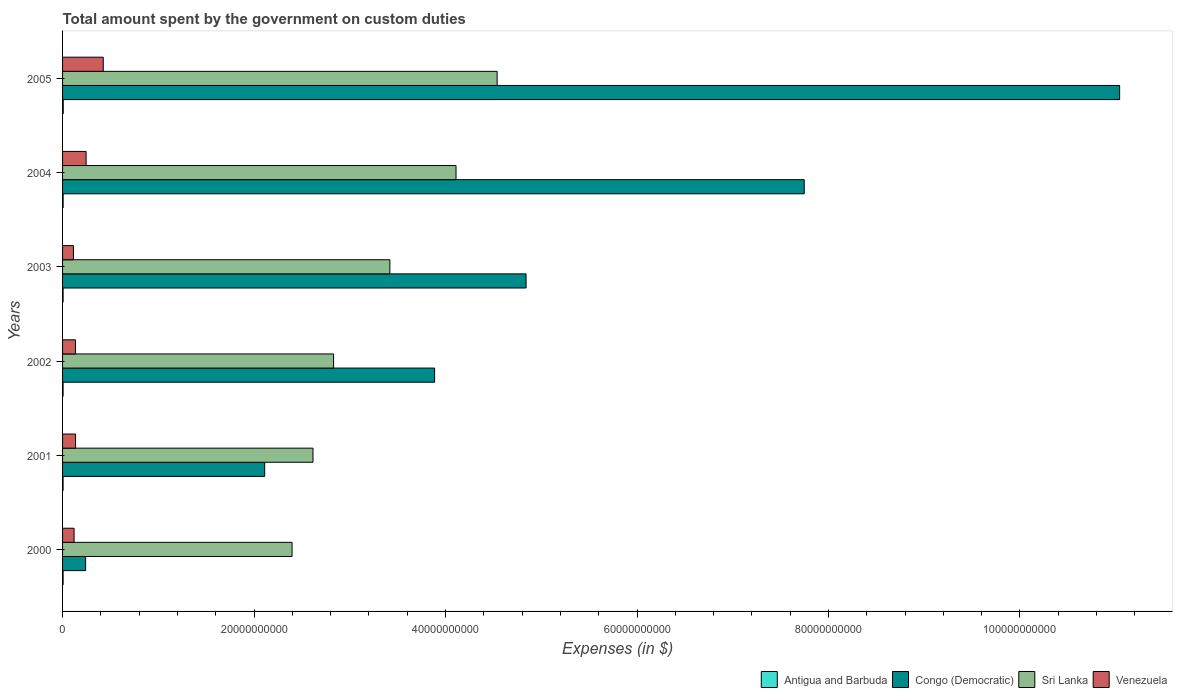How many groups of bars are there?
Provide a short and direct response. 6. How many bars are there on the 5th tick from the bottom?
Provide a short and direct response. 4. What is the amount spent on custom duties by the government in Venezuela in 2005?
Provide a short and direct response. 4.25e+09. Across all years, what is the maximum amount spent on custom duties by the government in Sri Lanka?
Provide a short and direct response. 4.54e+1. Across all years, what is the minimum amount spent on custom duties by the government in Sri Lanka?
Ensure brevity in your answer.  2.40e+1. In which year was the amount spent on custom duties by the government in Antigua and Barbuda maximum?
Make the answer very short. 2005. In which year was the amount spent on custom duties by the government in Congo (Democratic) minimum?
Your answer should be compact. 2000. What is the total amount spent on custom duties by the government in Sri Lanka in the graph?
Provide a short and direct response. 1.99e+11. What is the difference between the amount spent on custom duties by the government in Venezuela in 2000 and that in 2002?
Offer a very short reply. -1.48e+08. What is the difference between the amount spent on custom duties by the government in Congo (Democratic) in 2005 and the amount spent on custom duties by the government in Antigua and Barbuda in 2001?
Keep it short and to the point. 1.10e+11. What is the average amount spent on custom duties by the government in Congo (Democratic) per year?
Make the answer very short. 4.98e+1. In the year 2002, what is the difference between the amount spent on custom duties by the government in Sri Lanka and amount spent on custom duties by the government in Antigua and Barbuda?
Give a very brief answer. 2.83e+1. In how many years, is the amount spent on custom duties by the government in Sri Lanka greater than 32000000000 $?
Your answer should be compact. 3. What is the ratio of the amount spent on custom duties by the government in Congo (Democratic) in 2002 to that in 2004?
Offer a terse response. 0.5. What is the difference between the highest and the second highest amount spent on custom duties by the government in Antigua and Barbuda?
Your response must be concise. 1.07e+07. What is the difference between the highest and the lowest amount spent on custom duties by the government in Antigua and Barbuda?
Offer a terse response. 1.66e+07. Is it the case that in every year, the sum of the amount spent on custom duties by the government in Sri Lanka and amount spent on custom duties by the government in Venezuela is greater than the sum of amount spent on custom duties by the government in Congo (Democratic) and amount spent on custom duties by the government in Antigua and Barbuda?
Your answer should be compact. Yes. What does the 1st bar from the top in 2002 represents?
Your answer should be compact. Venezuela. What does the 2nd bar from the bottom in 2003 represents?
Give a very brief answer. Congo (Democratic). Does the graph contain any zero values?
Your answer should be compact. No. What is the title of the graph?
Provide a short and direct response. Total amount spent by the government on custom duties. Does "Latin America(all income levels)" appear as one of the legend labels in the graph?
Provide a short and direct response. No. What is the label or title of the X-axis?
Your response must be concise. Expenses (in $). What is the label or title of the Y-axis?
Your response must be concise. Years. What is the Expenses (in $) in Antigua and Barbuda in 2000?
Ensure brevity in your answer.  5.67e+07. What is the Expenses (in $) in Congo (Democratic) in 2000?
Provide a short and direct response. 2.41e+09. What is the Expenses (in $) in Sri Lanka in 2000?
Give a very brief answer. 2.40e+1. What is the Expenses (in $) in Venezuela in 2000?
Keep it short and to the point. 1.20e+09. What is the Expenses (in $) of Antigua and Barbuda in 2001?
Keep it short and to the point. 5.59e+07. What is the Expenses (in $) of Congo (Democratic) in 2001?
Make the answer very short. 2.11e+1. What is the Expenses (in $) in Sri Lanka in 2001?
Provide a succinct answer. 2.62e+1. What is the Expenses (in $) of Venezuela in 2001?
Give a very brief answer. 1.36e+09. What is the Expenses (in $) of Antigua and Barbuda in 2002?
Your response must be concise. 5.46e+07. What is the Expenses (in $) in Congo (Democratic) in 2002?
Your answer should be very brief. 3.89e+1. What is the Expenses (in $) of Sri Lanka in 2002?
Your answer should be compact. 2.83e+1. What is the Expenses (in $) in Venezuela in 2002?
Provide a succinct answer. 1.35e+09. What is the Expenses (in $) in Antigua and Barbuda in 2003?
Make the answer very short. 5.70e+07. What is the Expenses (in $) of Congo (Democratic) in 2003?
Make the answer very short. 4.84e+1. What is the Expenses (in $) of Sri Lanka in 2003?
Your answer should be very brief. 3.42e+1. What is the Expenses (in $) of Venezuela in 2003?
Keep it short and to the point. 1.14e+09. What is the Expenses (in $) of Antigua and Barbuda in 2004?
Make the answer very short. 6.05e+07. What is the Expenses (in $) in Congo (Democratic) in 2004?
Ensure brevity in your answer.  7.75e+1. What is the Expenses (in $) of Sri Lanka in 2004?
Your response must be concise. 4.11e+1. What is the Expenses (in $) of Venezuela in 2004?
Provide a succinct answer. 2.46e+09. What is the Expenses (in $) in Antigua and Barbuda in 2005?
Offer a terse response. 7.12e+07. What is the Expenses (in $) of Congo (Democratic) in 2005?
Give a very brief answer. 1.10e+11. What is the Expenses (in $) in Sri Lanka in 2005?
Ensure brevity in your answer.  4.54e+1. What is the Expenses (in $) in Venezuela in 2005?
Make the answer very short. 4.25e+09. Across all years, what is the maximum Expenses (in $) in Antigua and Barbuda?
Provide a short and direct response. 7.12e+07. Across all years, what is the maximum Expenses (in $) in Congo (Democratic)?
Ensure brevity in your answer.  1.10e+11. Across all years, what is the maximum Expenses (in $) in Sri Lanka?
Offer a very short reply. 4.54e+1. Across all years, what is the maximum Expenses (in $) in Venezuela?
Offer a terse response. 4.25e+09. Across all years, what is the minimum Expenses (in $) of Antigua and Barbuda?
Offer a very short reply. 5.46e+07. Across all years, what is the minimum Expenses (in $) in Congo (Democratic)?
Your answer should be very brief. 2.41e+09. Across all years, what is the minimum Expenses (in $) of Sri Lanka?
Offer a terse response. 2.40e+1. Across all years, what is the minimum Expenses (in $) in Venezuela?
Offer a very short reply. 1.14e+09. What is the total Expenses (in $) of Antigua and Barbuda in the graph?
Give a very brief answer. 3.56e+08. What is the total Expenses (in $) of Congo (Democratic) in the graph?
Offer a very short reply. 2.99e+11. What is the total Expenses (in $) of Sri Lanka in the graph?
Give a very brief answer. 1.99e+11. What is the total Expenses (in $) in Venezuela in the graph?
Ensure brevity in your answer.  1.18e+1. What is the difference between the Expenses (in $) of Congo (Democratic) in 2000 and that in 2001?
Offer a terse response. -1.87e+1. What is the difference between the Expenses (in $) in Sri Lanka in 2000 and that in 2001?
Make the answer very short. -2.19e+09. What is the difference between the Expenses (in $) in Venezuela in 2000 and that in 2001?
Your answer should be very brief. -1.52e+08. What is the difference between the Expenses (in $) of Antigua and Barbuda in 2000 and that in 2002?
Your answer should be compact. 2.10e+06. What is the difference between the Expenses (in $) in Congo (Democratic) in 2000 and that in 2002?
Offer a terse response. -3.65e+1. What is the difference between the Expenses (in $) of Sri Lanka in 2000 and that in 2002?
Offer a terse response. -4.34e+09. What is the difference between the Expenses (in $) in Venezuela in 2000 and that in 2002?
Make the answer very short. -1.48e+08. What is the difference between the Expenses (in $) in Antigua and Barbuda in 2000 and that in 2003?
Provide a short and direct response. -3.00e+05. What is the difference between the Expenses (in $) in Congo (Democratic) in 2000 and that in 2003?
Make the answer very short. -4.60e+1. What is the difference between the Expenses (in $) of Sri Lanka in 2000 and that in 2003?
Provide a succinct answer. -1.02e+1. What is the difference between the Expenses (in $) in Venezuela in 2000 and that in 2003?
Offer a terse response. 6.60e+07. What is the difference between the Expenses (in $) of Antigua and Barbuda in 2000 and that in 2004?
Keep it short and to the point. -3.80e+06. What is the difference between the Expenses (in $) of Congo (Democratic) in 2000 and that in 2004?
Make the answer very short. -7.51e+1. What is the difference between the Expenses (in $) of Sri Lanka in 2000 and that in 2004?
Give a very brief answer. -1.71e+1. What is the difference between the Expenses (in $) of Venezuela in 2000 and that in 2004?
Ensure brevity in your answer.  -1.25e+09. What is the difference between the Expenses (in $) of Antigua and Barbuda in 2000 and that in 2005?
Offer a very short reply. -1.45e+07. What is the difference between the Expenses (in $) in Congo (Democratic) in 2000 and that in 2005?
Your answer should be compact. -1.08e+11. What is the difference between the Expenses (in $) in Sri Lanka in 2000 and that in 2005?
Give a very brief answer. -2.14e+1. What is the difference between the Expenses (in $) of Venezuela in 2000 and that in 2005?
Your answer should be compact. -3.05e+09. What is the difference between the Expenses (in $) of Antigua and Barbuda in 2001 and that in 2002?
Keep it short and to the point. 1.30e+06. What is the difference between the Expenses (in $) in Congo (Democratic) in 2001 and that in 2002?
Ensure brevity in your answer.  -1.77e+1. What is the difference between the Expenses (in $) in Sri Lanka in 2001 and that in 2002?
Keep it short and to the point. -2.15e+09. What is the difference between the Expenses (in $) of Venezuela in 2001 and that in 2002?
Your answer should be very brief. 3.88e+06. What is the difference between the Expenses (in $) of Antigua and Barbuda in 2001 and that in 2003?
Ensure brevity in your answer.  -1.10e+06. What is the difference between the Expenses (in $) in Congo (Democratic) in 2001 and that in 2003?
Keep it short and to the point. -2.73e+1. What is the difference between the Expenses (in $) of Sri Lanka in 2001 and that in 2003?
Provide a short and direct response. -8.03e+09. What is the difference between the Expenses (in $) in Venezuela in 2001 and that in 2003?
Keep it short and to the point. 2.18e+08. What is the difference between the Expenses (in $) in Antigua and Barbuda in 2001 and that in 2004?
Provide a short and direct response. -4.60e+06. What is the difference between the Expenses (in $) of Congo (Democratic) in 2001 and that in 2004?
Offer a very short reply. -5.64e+1. What is the difference between the Expenses (in $) of Sri Lanka in 2001 and that in 2004?
Your response must be concise. -1.49e+1. What is the difference between the Expenses (in $) of Venezuela in 2001 and that in 2004?
Provide a succinct answer. -1.10e+09. What is the difference between the Expenses (in $) in Antigua and Barbuda in 2001 and that in 2005?
Your response must be concise. -1.53e+07. What is the difference between the Expenses (in $) in Congo (Democratic) in 2001 and that in 2005?
Give a very brief answer. -8.93e+1. What is the difference between the Expenses (in $) of Sri Lanka in 2001 and that in 2005?
Offer a terse response. -1.92e+1. What is the difference between the Expenses (in $) in Venezuela in 2001 and that in 2005?
Offer a very short reply. -2.89e+09. What is the difference between the Expenses (in $) of Antigua and Barbuda in 2002 and that in 2003?
Your answer should be very brief. -2.40e+06. What is the difference between the Expenses (in $) in Congo (Democratic) in 2002 and that in 2003?
Ensure brevity in your answer.  -9.55e+09. What is the difference between the Expenses (in $) of Sri Lanka in 2002 and that in 2003?
Ensure brevity in your answer.  -5.88e+09. What is the difference between the Expenses (in $) of Venezuela in 2002 and that in 2003?
Ensure brevity in your answer.  2.14e+08. What is the difference between the Expenses (in $) in Antigua and Barbuda in 2002 and that in 2004?
Keep it short and to the point. -5.90e+06. What is the difference between the Expenses (in $) in Congo (Democratic) in 2002 and that in 2004?
Give a very brief answer. -3.86e+1. What is the difference between the Expenses (in $) in Sri Lanka in 2002 and that in 2004?
Offer a terse response. -1.28e+1. What is the difference between the Expenses (in $) in Venezuela in 2002 and that in 2004?
Keep it short and to the point. -1.11e+09. What is the difference between the Expenses (in $) of Antigua and Barbuda in 2002 and that in 2005?
Provide a short and direct response. -1.66e+07. What is the difference between the Expenses (in $) in Congo (Democratic) in 2002 and that in 2005?
Your answer should be very brief. -7.15e+1. What is the difference between the Expenses (in $) in Sri Lanka in 2002 and that in 2005?
Provide a short and direct response. -1.71e+1. What is the difference between the Expenses (in $) of Venezuela in 2002 and that in 2005?
Keep it short and to the point. -2.90e+09. What is the difference between the Expenses (in $) of Antigua and Barbuda in 2003 and that in 2004?
Keep it short and to the point. -3.50e+06. What is the difference between the Expenses (in $) of Congo (Democratic) in 2003 and that in 2004?
Your answer should be compact. -2.91e+1. What is the difference between the Expenses (in $) of Sri Lanka in 2003 and that in 2004?
Keep it short and to the point. -6.91e+09. What is the difference between the Expenses (in $) of Venezuela in 2003 and that in 2004?
Provide a succinct answer. -1.32e+09. What is the difference between the Expenses (in $) of Antigua and Barbuda in 2003 and that in 2005?
Offer a very short reply. -1.42e+07. What is the difference between the Expenses (in $) in Congo (Democratic) in 2003 and that in 2005?
Your response must be concise. -6.20e+1. What is the difference between the Expenses (in $) in Sri Lanka in 2003 and that in 2005?
Your answer should be very brief. -1.12e+1. What is the difference between the Expenses (in $) of Venezuela in 2003 and that in 2005?
Your answer should be compact. -3.11e+09. What is the difference between the Expenses (in $) of Antigua and Barbuda in 2004 and that in 2005?
Your answer should be very brief. -1.07e+07. What is the difference between the Expenses (in $) in Congo (Democratic) in 2004 and that in 2005?
Give a very brief answer. -3.29e+1. What is the difference between the Expenses (in $) of Sri Lanka in 2004 and that in 2005?
Offer a terse response. -4.29e+09. What is the difference between the Expenses (in $) of Venezuela in 2004 and that in 2005?
Provide a short and direct response. -1.79e+09. What is the difference between the Expenses (in $) of Antigua and Barbuda in 2000 and the Expenses (in $) of Congo (Democratic) in 2001?
Offer a terse response. -2.11e+1. What is the difference between the Expenses (in $) in Antigua and Barbuda in 2000 and the Expenses (in $) in Sri Lanka in 2001?
Provide a short and direct response. -2.61e+1. What is the difference between the Expenses (in $) of Antigua and Barbuda in 2000 and the Expenses (in $) of Venezuela in 2001?
Keep it short and to the point. -1.30e+09. What is the difference between the Expenses (in $) in Congo (Democratic) in 2000 and the Expenses (in $) in Sri Lanka in 2001?
Make the answer very short. -2.37e+1. What is the difference between the Expenses (in $) of Congo (Democratic) in 2000 and the Expenses (in $) of Venezuela in 2001?
Your answer should be very brief. 1.05e+09. What is the difference between the Expenses (in $) of Sri Lanka in 2000 and the Expenses (in $) of Venezuela in 2001?
Give a very brief answer. 2.26e+1. What is the difference between the Expenses (in $) of Antigua and Barbuda in 2000 and the Expenses (in $) of Congo (Democratic) in 2002?
Your response must be concise. -3.88e+1. What is the difference between the Expenses (in $) in Antigua and Barbuda in 2000 and the Expenses (in $) in Sri Lanka in 2002?
Your response must be concise. -2.83e+1. What is the difference between the Expenses (in $) in Antigua and Barbuda in 2000 and the Expenses (in $) in Venezuela in 2002?
Your answer should be very brief. -1.29e+09. What is the difference between the Expenses (in $) of Congo (Democratic) in 2000 and the Expenses (in $) of Sri Lanka in 2002?
Offer a terse response. -2.59e+1. What is the difference between the Expenses (in $) in Congo (Democratic) in 2000 and the Expenses (in $) in Venezuela in 2002?
Make the answer very short. 1.05e+09. What is the difference between the Expenses (in $) in Sri Lanka in 2000 and the Expenses (in $) in Venezuela in 2002?
Your response must be concise. 2.26e+1. What is the difference between the Expenses (in $) in Antigua and Barbuda in 2000 and the Expenses (in $) in Congo (Democratic) in 2003?
Your answer should be very brief. -4.84e+1. What is the difference between the Expenses (in $) in Antigua and Barbuda in 2000 and the Expenses (in $) in Sri Lanka in 2003?
Provide a short and direct response. -3.41e+1. What is the difference between the Expenses (in $) in Antigua and Barbuda in 2000 and the Expenses (in $) in Venezuela in 2003?
Your answer should be very brief. -1.08e+09. What is the difference between the Expenses (in $) of Congo (Democratic) in 2000 and the Expenses (in $) of Sri Lanka in 2003?
Make the answer very short. -3.18e+1. What is the difference between the Expenses (in $) of Congo (Democratic) in 2000 and the Expenses (in $) of Venezuela in 2003?
Make the answer very short. 1.27e+09. What is the difference between the Expenses (in $) of Sri Lanka in 2000 and the Expenses (in $) of Venezuela in 2003?
Ensure brevity in your answer.  2.28e+1. What is the difference between the Expenses (in $) in Antigua and Barbuda in 2000 and the Expenses (in $) in Congo (Democratic) in 2004?
Your answer should be compact. -7.74e+1. What is the difference between the Expenses (in $) in Antigua and Barbuda in 2000 and the Expenses (in $) in Sri Lanka in 2004?
Make the answer very short. -4.10e+1. What is the difference between the Expenses (in $) in Antigua and Barbuda in 2000 and the Expenses (in $) in Venezuela in 2004?
Your answer should be very brief. -2.40e+09. What is the difference between the Expenses (in $) of Congo (Democratic) in 2000 and the Expenses (in $) of Sri Lanka in 2004?
Your response must be concise. -3.87e+1. What is the difference between the Expenses (in $) of Congo (Democratic) in 2000 and the Expenses (in $) of Venezuela in 2004?
Provide a succinct answer. -5.08e+07. What is the difference between the Expenses (in $) in Sri Lanka in 2000 and the Expenses (in $) in Venezuela in 2004?
Your answer should be compact. 2.15e+1. What is the difference between the Expenses (in $) in Antigua and Barbuda in 2000 and the Expenses (in $) in Congo (Democratic) in 2005?
Keep it short and to the point. -1.10e+11. What is the difference between the Expenses (in $) in Antigua and Barbuda in 2000 and the Expenses (in $) in Sri Lanka in 2005?
Offer a terse response. -4.53e+1. What is the difference between the Expenses (in $) of Antigua and Barbuda in 2000 and the Expenses (in $) of Venezuela in 2005?
Your response must be concise. -4.19e+09. What is the difference between the Expenses (in $) in Congo (Democratic) in 2000 and the Expenses (in $) in Sri Lanka in 2005?
Provide a succinct answer. -4.30e+1. What is the difference between the Expenses (in $) of Congo (Democratic) in 2000 and the Expenses (in $) of Venezuela in 2005?
Ensure brevity in your answer.  -1.84e+09. What is the difference between the Expenses (in $) of Sri Lanka in 2000 and the Expenses (in $) of Venezuela in 2005?
Your answer should be compact. 1.97e+1. What is the difference between the Expenses (in $) in Antigua and Barbuda in 2001 and the Expenses (in $) in Congo (Democratic) in 2002?
Offer a terse response. -3.88e+1. What is the difference between the Expenses (in $) in Antigua and Barbuda in 2001 and the Expenses (in $) in Sri Lanka in 2002?
Make the answer very short. -2.83e+1. What is the difference between the Expenses (in $) in Antigua and Barbuda in 2001 and the Expenses (in $) in Venezuela in 2002?
Provide a short and direct response. -1.30e+09. What is the difference between the Expenses (in $) in Congo (Democratic) in 2001 and the Expenses (in $) in Sri Lanka in 2002?
Provide a succinct answer. -7.20e+09. What is the difference between the Expenses (in $) of Congo (Democratic) in 2001 and the Expenses (in $) of Venezuela in 2002?
Your response must be concise. 1.98e+1. What is the difference between the Expenses (in $) in Sri Lanka in 2001 and the Expenses (in $) in Venezuela in 2002?
Provide a succinct answer. 2.48e+1. What is the difference between the Expenses (in $) in Antigua and Barbuda in 2001 and the Expenses (in $) in Congo (Democratic) in 2003?
Provide a succinct answer. -4.84e+1. What is the difference between the Expenses (in $) in Antigua and Barbuda in 2001 and the Expenses (in $) in Sri Lanka in 2003?
Make the answer very short. -3.41e+1. What is the difference between the Expenses (in $) of Antigua and Barbuda in 2001 and the Expenses (in $) of Venezuela in 2003?
Your answer should be very brief. -1.08e+09. What is the difference between the Expenses (in $) in Congo (Democratic) in 2001 and the Expenses (in $) in Sri Lanka in 2003?
Offer a very short reply. -1.31e+1. What is the difference between the Expenses (in $) in Congo (Democratic) in 2001 and the Expenses (in $) in Venezuela in 2003?
Ensure brevity in your answer.  2.00e+1. What is the difference between the Expenses (in $) of Sri Lanka in 2001 and the Expenses (in $) of Venezuela in 2003?
Keep it short and to the point. 2.50e+1. What is the difference between the Expenses (in $) in Antigua and Barbuda in 2001 and the Expenses (in $) in Congo (Democratic) in 2004?
Your answer should be compact. -7.74e+1. What is the difference between the Expenses (in $) in Antigua and Barbuda in 2001 and the Expenses (in $) in Sri Lanka in 2004?
Your answer should be compact. -4.10e+1. What is the difference between the Expenses (in $) in Antigua and Barbuda in 2001 and the Expenses (in $) in Venezuela in 2004?
Your answer should be compact. -2.40e+09. What is the difference between the Expenses (in $) in Congo (Democratic) in 2001 and the Expenses (in $) in Sri Lanka in 2004?
Ensure brevity in your answer.  -2.00e+1. What is the difference between the Expenses (in $) of Congo (Democratic) in 2001 and the Expenses (in $) of Venezuela in 2004?
Give a very brief answer. 1.87e+1. What is the difference between the Expenses (in $) of Sri Lanka in 2001 and the Expenses (in $) of Venezuela in 2004?
Your answer should be very brief. 2.37e+1. What is the difference between the Expenses (in $) of Antigua and Barbuda in 2001 and the Expenses (in $) of Congo (Democratic) in 2005?
Make the answer very short. -1.10e+11. What is the difference between the Expenses (in $) in Antigua and Barbuda in 2001 and the Expenses (in $) in Sri Lanka in 2005?
Give a very brief answer. -4.53e+1. What is the difference between the Expenses (in $) in Antigua and Barbuda in 2001 and the Expenses (in $) in Venezuela in 2005?
Your answer should be very brief. -4.19e+09. What is the difference between the Expenses (in $) of Congo (Democratic) in 2001 and the Expenses (in $) of Sri Lanka in 2005?
Your response must be concise. -2.43e+1. What is the difference between the Expenses (in $) of Congo (Democratic) in 2001 and the Expenses (in $) of Venezuela in 2005?
Your answer should be compact. 1.69e+1. What is the difference between the Expenses (in $) in Sri Lanka in 2001 and the Expenses (in $) in Venezuela in 2005?
Keep it short and to the point. 2.19e+1. What is the difference between the Expenses (in $) in Antigua and Barbuda in 2002 and the Expenses (in $) in Congo (Democratic) in 2003?
Your answer should be compact. -4.84e+1. What is the difference between the Expenses (in $) in Antigua and Barbuda in 2002 and the Expenses (in $) in Sri Lanka in 2003?
Your answer should be very brief. -3.41e+1. What is the difference between the Expenses (in $) of Antigua and Barbuda in 2002 and the Expenses (in $) of Venezuela in 2003?
Ensure brevity in your answer.  -1.08e+09. What is the difference between the Expenses (in $) of Congo (Democratic) in 2002 and the Expenses (in $) of Sri Lanka in 2003?
Ensure brevity in your answer.  4.67e+09. What is the difference between the Expenses (in $) in Congo (Democratic) in 2002 and the Expenses (in $) in Venezuela in 2003?
Your answer should be very brief. 3.77e+1. What is the difference between the Expenses (in $) of Sri Lanka in 2002 and the Expenses (in $) of Venezuela in 2003?
Give a very brief answer. 2.72e+1. What is the difference between the Expenses (in $) in Antigua and Barbuda in 2002 and the Expenses (in $) in Congo (Democratic) in 2004?
Offer a very short reply. -7.74e+1. What is the difference between the Expenses (in $) of Antigua and Barbuda in 2002 and the Expenses (in $) of Sri Lanka in 2004?
Offer a very short reply. -4.10e+1. What is the difference between the Expenses (in $) of Antigua and Barbuda in 2002 and the Expenses (in $) of Venezuela in 2004?
Offer a very short reply. -2.40e+09. What is the difference between the Expenses (in $) of Congo (Democratic) in 2002 and the Expenses (in $) of Sri Lanka in 2004?
Your answer should be compact. -2.24e+09. What is the difference between the Expenses (in $) of Congo (Democratic) in 2002 and the Expenses (in $) of Venezuela in 2004?
Offer a very short reply. 3.64e+1. What is the difference between the Expenses (in $) in Sri Lanka in 2002 and the Expenses (in $) in Venezuela in 2004?
Ensure brevity in your answer.  2.59e+1. What is the difference between the Expenses (in $) of Antigua and Barbuda in 2002 and the Expenses (in $) of Congo (Democratic) in 2005?
Offer a terse response. -1.10e+11. What is the difference between the Expenses (in $) in Antigua and Barbuda in 2002 and the Expenses (in $) in Sri Lanka in 2005?
Ensure brevity in your answer.  -4.53e+1. What is the difference between the Expenses (in $) of Antigua and Barbuda in 2002 and the Expenses (in $) of Venezuela in 2005?
Keep it short and to the point. -4.20e+09. What is the difference between the Expenses (in $) in Congo (Democratic) in 2002 and the Expenses (in $) in Sri Lanka in 2005?
Your response must be concise. -6.53e+09. What is the difference between the Expenses (in $) of Congo (Democratic) in 2002 and the Expenses (in $) of Venezuela in 2005?
Provide a short and direct response. 3.46e+1. What is the difference between the Expenses (in $) in Sri Lanka in 2002 and the Expenses (in $) in Venezuela in 2005?
Your response must be concise. 2.41e+1. What is the difference between the Expenses (in $) in Antigua and Barbuda in 2003 and the Expenses (in $) in Congo (Democratic) in 2004?
Offer a terse response. -7.74e+1. What is the difference between the Expenses (in $) in Antigua and Barbuda in 2003 and the Expenses (in $) in Sri Lanka in 2004?
Make the answer very short. -4.10e+1. What is the difference between the Expenses (in $) in Antigua and Barbuda in 2003 and the Expenses (in $) in Venezuela in 2004?
Offer a very short reply. -2.40e+09. What is the difference between the Expenses (in $) in Congo (Democratic) in 2003 and the Expenses (in $) in Sri Lanka in 2004?
Make the answer very short. 7.32e+09. What is the difference between the Expenses (in $) in Congo (Democratic) in 2003 and the Expenses (in $) in Venezuela in 2004?
Your answer should be very brief. 4.60e+1. What is the difference between the Expenses (in $) in Sri Lanka in 2003 and the Expenses (in $) in Venezuela in 2004?
Offer a very short reply. 3.17e+1. What is the difference between the Expenses (in $) in Antigua and Barbuda in 2003 and the Expenses (in $) in Congo (Democratic) in 2005?
Provide a succinct answer. -1.10e+11. What is the difference between the Expenses (in $) of Antigua and Barbuda in 2003 and the Expenses (in $) of Sri Lanka in 2005?
Offer a terse response. -4.53e+1. What is the difference between the Expenses (in $) in Antigua and Barbuda in 2003 and the Expenses (in $) in Venezuela in 2005?
Offer a terse response. -4.19e+09. What is the difference between the Expenses (in $) in Congo (Democratic) in 2003 and the Expenses (in $) in Sri Lanka in 2005?
Your response must be concise. 3.02e+09. What is the difference between the Expenses (in $) in Congo (Democratic) in 2003 and the Expenses (in $) in Venezuela in 2005?
Your response must be concise. 4.42e+1. What is the difference between the Expenses (in $) of Sri Lanka in 2003 and the Expenses (in $) of Venezuela in 2005?
Offer a very short reply. 2.99e+1. What is the difference between the Expenses (in $) in Antigua and Barbuda in 2004 and the Expenses (in $) in Congo (Democratic) in 2005?
Provide a short and direct response. -1.10e+11. What is the difference between the Expenses (in $) of Antigua and Barbuda in 2004 and the Expenses (in $) of Sri Lanka in 2005?
Provide a short and direct response. -4.53e+1. What is the difference between the Expenses (in $) of Antigua and Barbuda in 2004 and the Expenses (in $) of Venezuela in 2005?
Offer a terse response. -4.19e+09. What is the difference between the Expenses (in $) of Congo (Democratic) in 2004 and the Expenses (in $) of Sri Lanka in 2005?
Keep it short and to the point. 3.21e+1. What is the difference between the Expenses (in $) in Congo (Democratic) in 2004 and the Expenses (in $) in Venezuela in 2005?
Ensure brevity in your answer.  7.32e+1. What is the difference between the Expenses (in $) of Sri Lanka in 2004 and the Expenses (in $) of Venezuela in 2005?
Keep it short and to the point. 3.68e+1. What is the average Expenses (in $) of Antigua and Barbuda per year?
Provide a succinct answer. 5.93e+07. What is the average Expenses (in $) of Congo (Democratic) per year?
Make the answer very short. 4.98e+1. What is the average Expenses (in $) in Sri Lanka per year?
Keep it short and to the point. 3.32e+1. What is the average Expenses (in $) in Venezuela per year?
Give a very brief answer. 1.96e+09. In the year 2000, what is the difference between the Expenses (in $) of Antigua and Barbuda and Expenses (in $) of Congo (Democratic)?
Offer a very short reply. -2.35e+09. In the year 2000, what is the difference between the Expenses (in $) in Antigua and Barbuda and Expenses (in $) in Sri Lanka?
Your answer should be compact. -2.39e+1. In the year 2000, what is the difference between the Expenses (in $) in Antigua and Barbuda and Expenses (in $) in Venezuela?
Offer a very short reply. -1.15e+09. In the year 2000, what is the difference between the Expenses (in $) of Congo (Democratic) and Expenses (in $) of Sri Lanka?
Your response must be concise. -2.16e+1. In the year 2000, what is the difference between the Expenses (in $) in Congo (Democratic) and Expenses (in $) in Venezuela?
Give a very brief answer. 1.20e+09. In the year 2000, what is the difference between the Expenses (in $) of Sri Lanka and Expenses (in $) of Venezuela?
Your answer should be compact. 2.28e+1. In the year 2001, what is the difference between the Expenses (in $) of Antigua and Barbuda and Expenses (in $) of Congo (Democratic)?
Provide a short and direct response. -2.11e+1. In the year 2001, what is the difference between the Expenses (in $) of Antigua and Barbuda and Expenses (in $) of Sri Lanka?
Provide a succinct answer. -2.61e+1. In the year 2001, what is the difference between the Expenses (in $) in Antigua and Barbuda and Expenses (in $) in Venezuela?
Give a very brief answer. -1.30e+09. In the year 2001, what is the difference between the Expenses (in $) in Congo (Democratic) and Expenses (in $) in Sri Lanka?
Your answer should be compact. -5.04e+09. In the year 2001, what is the difference between the Expenses (in $) in Congo (Democratic) and Expenses (in $) in Venezuela?
Your answer should be very brief. 1.98e+1. In the year 2001, what is the difference between the Expenses (in $) in Sri Lanka and Expenses (in $) in Venezuela?
Provide a short and direct response. 2.48e+1. In the year 2002, what is the difference between the Expenses (in $) of Antigua and Barbuda and Expenses (in $) of Congo (Democratic)?
Give a very brief answer. -3.88e+1. In the year 2002, what is the difference between the Expenses (in $) in Antigua and Barbuda and Expenses (in $) in Sri Lanka?
Ensure brevity in your answer.  -2.83e+1. In the year 2002, what is the difference between the Expenses (in $) of Antigua and Barbuda and Expenses (in $) of Venezuela?
Your answer should be compact. -1.30e+09. In the year 2002, what is the difference between the Expenses (in $) in Congo (Democratic) and Expenses (in $) in Sri Lanka?
Keep it short and to the point. 1.06e+1. In the year 2002, what is the difference between the Expenses (in $) in Congo (Democratic) and Expenses (in $) in Venezuela?
Keep it short and to the point. 3.75e+1. In the year 2002, what is the difference between the Expenses (in $) of Sri Lanka and Expenses (in $) of Venezuela?
Make the answer very short. 2.70e+1. In the year 2003, what is the difference between the Expenses (in $) of Antigua and Barbuda and Expenses (in $) of Congo (Democratic)?
Provide a succinct answer. -4.84e+1. In the year 2003, what is the difference between the Expenses (in $) in Antigua and Barbuda and Expenses (in $) in Sri Lanka?
Offer a terse response. -3.41e+1. In the year 2003, what is the difference between the Expenses (in $) in Antigua and Barbuda and Expenses (in $) in Venezuela?
Give a very brief answer. -1.08e+09. In the year 2003, what is the difference between the Expenses (in $) of Congo (Democratic) and Expenses (in $) of Sri Lanka?
Provide a short and direct response. 1.42e+1. In the year 2003, what is the difference between the Expenses (in $) in Congo (Democratic) and Expenses (in $) in Venezuela?
Offer a terse response. 4.73e+1. In the year 2003, what is the difference between the Expenses (in $) of Sri Lanka and Expenses (in $) of Venezuela?
Provide a short and direct response. 3.30e+1. In the year 2004, what is the difference between the Expenses (in $) of Antigua and Barbuda and Expenses (in $) of Congo (Democratic)?
Offer a very short reply. -7.74e+1. In the year 2004, what is the difference between the Expenses (in $) in Antigua and Barbuda and Expenses (in $) in Sri Lanka?
Your response must be concise. -4.10e+1. In the year 2004, what is the difference between the Expenses (in $) in Antigua and Barbuda and Expenses (in $) in Venezuela?
Your answer should be very brief. -2.40e+09. In the year 2004, what is the difference between the Expenses (in $) of Congo (Democratic) and Expenses (in $) of Sri Lanka?
Your answer should be very brief. 3.64e+1. In the year 2004, what is the difference between the Expenses (in $) in Congo (Democratic) and Expenses (in $) in Venezuela?
Provide a succinct answer. 7.50e+1. In the year 2004, what is the difference between the Expenses (in $) in Sri Lanka and Expenses (in $) in Venezuela?
Your answer should be compact. 3.86e+1. In the year 2005, what is the difference between the Expenses (in $) in Antigua and Barbuda and Expenses (in $) in Congo (Democratic)?
Provide a succinct answer. -1.10e+11. In the year 2005, what is the difference between the Expenses (in $) of Antigua and Barbuda and Expenses (in $) of Sri Lanka?
Offer a very short reply. -4.53e+1. In the year 2005, what is the difference between the Expenses (in $) of Antigua and Barbuda and Expenses (in $) of Venezuela?
Make the answer very short. -4.18e+09. In the year 2005, what is the difference between the Expenses (in $) of Congo (Democratic) and Expenses (in $) of Sri Lanka?
Ensure brevity in your answer.  6.50e+1. In the year 2005, what is the difference between the Expenses (in $) in Congo (Democratic) and Expenses (in $) in Venezuela?
Your response must be concise. 1.06e+11. In the year 2005, what is the difference between the Expenses (in $) in Sri Lanka and Expenses (in $) in Venezuela?
Provide a short and direct response. 4.11e+1. What is the ratio of the Expenses (in $) in Antigua and Barbuda in 2000 to that in 2001?
Your response must be concise. 1.01. What is the ratio of the Expenses (in $) in Congo (Democratic) in 2000 to that in 2001?
Keep it short and to the point. 0.11. What is the ratio of the Expenses (in $) in Sri Lanka in 2000 to that in 2001?
Provide a succinct answer. 0.92. What is the ratio of the Expenses (in $) in Venezuela in 2000 to that in 2001?
Provide a short and direct response. 0.89. What is the ratio of the Expenses (in $) in Antigua and Barbuda in 2000 to that in 2002?
Ensure brevity in your answer.  1.04. What is the ratio of the Expenses (in $) in Congo (Democratic) in 2000 to that in 2002?
Your answer should be very brief. 0.06. What is the ratio of the Expenses (in $) of Sri Lanka in 2000 to that in 2002?
Give a very brief answer. 0.85. What is the ratio of the Expenses (in $) in Venezuela in 2000 to that in 2002?
Provide a short and direct response. 0.89. What is the ratio of the Expenses (in $) in Congo (Democratic) in 2000 to that in 2003?
Give a very brief answer. 0.05. What is the ratio of the Expenses (in $) in Sri Lanka in 2000 to that in 2003?
Provide a short and direct response. 0.7. What is the ratio of the Expenses (in $) in Venezuela in 2000 to that in 2003?
Ensure brevity in your answer.  1.06. What is the ratio of the Expenses (in $) in Antigua and Barbuda in 2000 to that in 2004?
Provide a short and direct response. 0.94. What is the ratio of the Expenses (in $) in Congo (Democratic) in 2000 to that in 2004?
Provide a short and direct response. 0.03. What is the ratio of the Expenses (in $) in Sri Lanka in 2000 to that in 2004?
Your answer should be very brief. 0.58. What is the ratio of the Expenses (in $) of Venezuela in 2000 to that in 2004?
Keep it short and to the point. 0.49. What is the ratio of the Expenses (in $) in Antigua and Barbuda in 2000 to that in 2005?
Give a very brief answer. 0.8. What is the ratio of the Expenses (in $) of Congo (Democratic) in 2000 to that in 2005?
Provide a succinct answer. 0.02. What is the ratio of the Expenses (in $) of Sri Lanka in 2000 to that in 2005?
Give a very brief answer. 0.53. What is the ratio of the Expenses (in $) of Venezuela in 2000 to that in 2005?
Your response must be concise. 0.28. What is the ratio of the Expenses (in $) of Antigua and Barbuda in 2001 to that in 2002?
Provide a succinct answer. 1.02. What is the ratio of the Expenses (in $) of Congo (Democratic) in 2001 to that in 2002?
Keep it short and to the point. 0.54. What is the ratio of the Expenses (in $) of Sri Lanka in 2001 to that in 2002?
Give a very brief answer. 0.92. What is the ratio of the Expenses (in $) of Venezuela in 2001 to that in 2002?
Your answer should be very brief. 1. What is the ratio of the Expenses (in $) in Antigua and Barbuda in 2001 to that in 2003?
Your response must be concise. 0.98. What is the ratio of the Expenses (in $) in Congo (Democratic) in 2001 to that in 2003?
Make the answer very short. 0.44. What is the ratio of the Expenses (in $) of Sri Lanka in 2001 to that in 2003?
Provide a succinct answer. 0.77. What is the ratio of the Expenses (in $) of Venezuela in 2001 to that in 2003?
Ensure brevity in your answer.  1.19. What is the ratio of the Expenses (in $) of Antigua and Barbuda in 2001 to that in 2004?
Give a very brief answer. 0.92. What is the ratio of the Expenses (in $) in Congo (Democratic) in 2001 to that in 2004?
Ensure brevity in your answer.  0.27. What is the ratio of the Expenses (in $) of Sri Lanka in 2001 to that in 2004?
Ensure brevity in your answer.  0.64. What is the ratio of the Expenses (in $) of Venezuela in 2001 to that in 2004?
Your response must be concise. 0.55. What is the ratio of the Expenses (in $) in Antigua and Barbuda in 2001 to that in 2005?
Offer a terse response. 0.79. What is the ratio of the Expenses (in $) of Congo (Democratic) in 2001 to that in 2005?
Give a very brief answer. 0.19. What is the ratio of the Expenses (in $) in Sri Lanka in 2001 to that in 2005?
Your response must be concise. 0.58. What is the ratio of the Expenses (in $) of Venezuela in 2001 to that in 2005?
Your answer should be compact. 0.32. What is the ratio of the Expenses (in $) of Antigua and Barbuda in 2002 to that in 2003?
Provide a succinct answer. 0.96. What is the ratio of the Expenses (in $) in Congo (Democratic) in 2002 to that in 2003?
Provide a succinct answer. 0.8. What is the ratio of the Expenses (in $) in Sri Lanka in 2002 to that in 2003?
Offer a terse response. 0.83. What is the ratio of the Expenses (in $) in Venezuela in 2002 to that in 2003?
Your answer should be compact. 1.19. What is the ratio of the Expenses (in $) of Antigua and Barbuda in 2002 to that in 2004?
Offer a very short reply. 0.9. What is the ratio of the Expenses (in $) of Congo (Democratic) in 2002 to that in 2004?
Give a very brief answer. 0.5. What is the ratio of the Expenses (in $) of Sri Lanka in 2002 to that in 2004?
Provide a short and direct response. 0.69. What is the ratio of the Expenses (in $) in Venezuela in 2002 to that in 2004?
Make the answer very short. 0.55. What is the ratio of the Expenses (in $) of Antigua and Barbuda in 2002 to that in 2005?
Provide a short and direct response. 0.77. What is the ratio of the Expenses (in $) in Congo (Democratic) in 2002 to that in 2005?
Your answer should be compact. 0.35. What is the ratio of the Expenses (in $) in Sri Lanka in 2002 to that in 2005?
Make the answer very short. 0.62. What is the ratio of the Expenses (in $) in Venezuela in 2002 to that in 2005?
Provide a short and direct response. 0.32. What is the ratio of the Expenses (in $) in Antigua and Barbuda in 2003 to that in 2004?
Your answer should be very brief. 0.94. What is the ratio of the Expenses (in $) in Congo (Democratic) in 2003 to that in 2004?
Provide a short and direct response. 0.62. What is the ratio of the Expenses (in $) in Sri Lanka in 2003 to that in 2004?
Your answer should be very brief. 0.83. What is the ratio of the Expenses (in $) in Venezuela in 2003 to that in 2004?
Make the answer very short. 0.46. What is the ratio of the Expenses (in $) of Antigua and Barbuda in 2003 to that in 2005?
Your answer should be very brief. 0.8. What is the ratio of the Expenses (in $) of Congo (Democratic) in 2003 to that in 2005?
Offer a very short reply. 0.44. What is the ratio of the Expenses (in $) in Sri Lanka in 2003 to that in 2005?
Offer a very short reply. 0.75. What is the ratio of the Expenses (in $) of Venezuela in 2003 to that in 2005?
Ensure brevity in your answer.  0.27. What is the ratio of the Expenses (in $) of Antigua and Barbuda in 2004 to that in 2005?
Offer a very short reply. 0.85. What is the ratio of the Expenses (in $) in Congo (Democratic) in 2004 to that in 2005?
Provide a short and direct response. 0.7. What is the ratio of the Expenses (in $) in Sri Lanka in 2004 to that in 2005?
Make the answer very short. 0.91. What is the ratio of the Expenses (in $) in Venezuela in 2004 to that in 2005?
Provide a short and direct response. 0.58. What is the difference between the highest and the second highest Expenses (in $) in Antigua and Barbuda?
Ensure brevity in your answer.  1.07e+07. What is the difference between the highest and the second highest Expenses (in $) of Congo (Democratic)?
Your answer should be compact. 3.29e+1. What is the difference between the highest and the second highest Expenses (in $) in Sri Lanka?
Ensure brevity in your answer.  4.29e+09. What is the difference between the highest and the second highest Expenses (in $) of Venezuela?
Keep it short and to the point. 1.79e+09. What is the difference between the highest and the lowest Expenses (in $) of Antigua and Barbuda?
Your answer should be very brief. 1.66e+07. What is the difference between the highest and the lowest Expenses (in $) of Congo (Democratic)?
Make the answer very short. 1.08e+11. What is the difference between the highest and the lowest Expenses (in $) of Sri Lanka?
Give a very brief answer. 2.14e+1. What is the difference between the highest and the lowest Expenses (in $) in Venezuela?
Your answer should be very brief. 3.11e+09. 